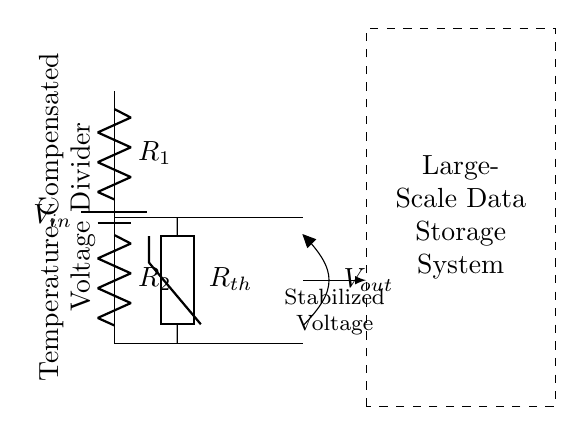What are the main components of this circuit? The circuit consists of two resistors (R1 and R2), a thermistor (Rth), and a power supply (Vin).
Answer: two resistors, thermistor, power supply What is the purpose of the thermistor in this circuit? The thermistor is used for temperature compensation, helping to stabilize the output voltage against temperature fluctuations.
Answer: temperature compensation What is the output voltage labeled in the diagram? The output voltage is marked as Vout in the circuit, indicating where the stabilized voltage is taken from.
Answer: Vout How do the resistors R1 and R2 relate to the output voltage? R1 and R2 create a voltage divider, which determines the output voltage Vout based on their resistance values and Vin.
Answer: voltage divider What can be inferred about the objective of this voltage divider circuit? The circuit is designed to stabilize voltage levels in a large-scale data storage system, indicated by the dashed rectangle label.
Answer: stabilize voltage levels How does temperature affect the voltage output of this divider? The thermistor adjusts its resistance based on temperature changes, which in turn affects the voltage output Vout, maintaining stability despite environmental variations.
Answer: voltage stability 